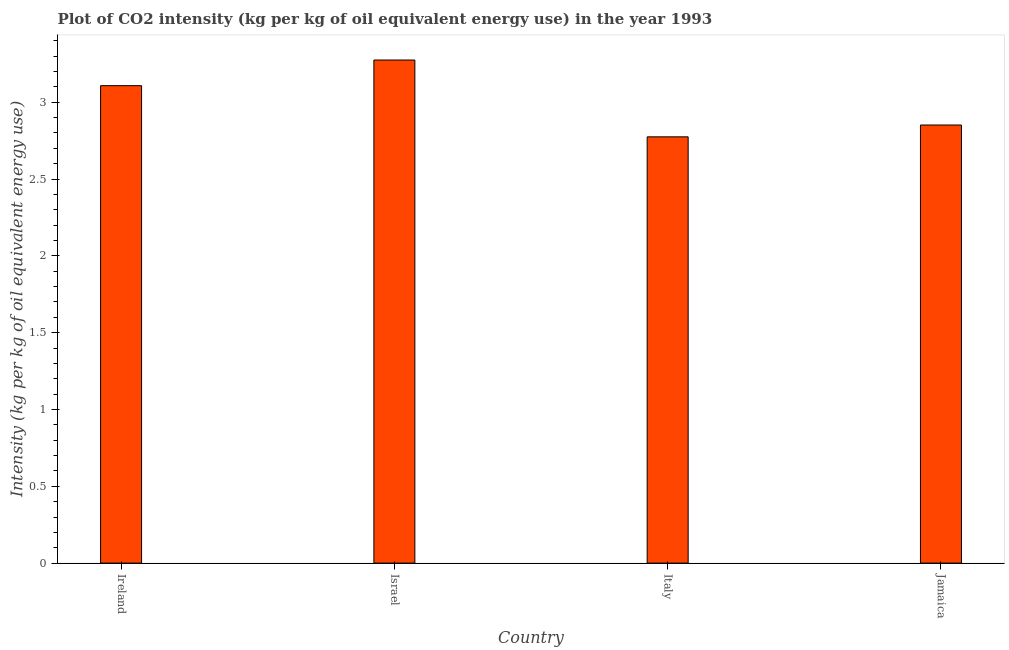Does the graph contain any zero values?
Offer a very short reply. No. What is the title of the graph?
Provide a short and direct response. Plot of CO2 intensity (kg per kg of oil equivalent energy use) in the year 1993. What is the label or title of the Y-axis?
Your answer should be very brief. Intensity (kg per kg of oil equivalent energy use). What is the co2 intensity in Jamaica?
Keep it short and to the point. 2.85. Across all countries, what is the maximum co2 intensity?
Ensure brevity in your answer.  3.27. Across all countries, what is the minimum co2 intensity?
Ensure brevity in your answer.  2.77. In which country was the co2 intensity minimum?
Offer a terse response. Italy. What is the sum of the co2 intensity?
Your response must be concise. 12.01. What is the difference between the co2 intensity in Israel and Jamaica?
Your answer should be very brief. 0.42. What is the average co2 intensity per country?
Your answer should be compact. 3. What is the median co2 intensity?
Provide a short and direct response. 2.98. In how many countries, is the co2 intensity greater than 2.7 kg?
Keep it short and to the point. 4. What is the ratio of the co2 intensity in Ireland to that in Israel?
Your answer should be compact. 0.95. Is the co2 intensity in Ireland less than that in Jamaica?
Offer a very short reply. No. Is the difference between the co2 intensity in Israel and Jamaica greater than the difference between any two countries?
Ensure brevity in your answer.  No. What is the difference between the highest and the second highest co2 intensity?
Make the answer very short. 0.17. In how many countries, is the co2 intensity greater than the average co2 intensity taken over all countries?
Your response must be concise. 2. How many bars are there?
Your response must be concise. 4. Are all the bars in the graph horizontal?
Ensure brevity in your answer.  No. How many countries are there in the graph?
Your answer should be compact. 4. Are the values on the major ticks of Y-axis written in scientific E-notation?
Keep it short and to the point. No. What is the Intensity (kg per kg of oil equivalent energy use) of Ireland?
Your response must be concise. 3.11. What is the Intensity (kg per kg of oil equivalent energy use) of Israel?
Offer a terse response. 3.27. What is the Intensity (kg per kg of oil equivalent energy use) in Italy?
Your answer should be compact. 2.77. What is the Intensity (kg per kg of oil equivalent energy use) in Jamaica?
Keep it short and to the point. 2.85. What is the difference between the Intensity (kg per kg of oil equivalent energy use) in Ireland and Israel?
Ensure brevity in your answer.  -0.17. What is the difference between the Intensity (kg per kg of oil equivalent energy use) in Ireland and Italy?
Make the answer very short. 0.33. What is the difference between the Intensity (kg per kg of oil equivalent energy use) in Ireland and Jamaica?
Ensure brevity in your answer.  0.26. What is the difference between the Intensity (kg per kg of oil equivalent energy use) in Israel and Italy?
Your response must be concise. 0.5. What is the difference between the Intensity (kg per kg of oil equivalent energy use) in Israel and Jamaica?
Your answer should be compact. 0.42. What is the difference between the Intensity (kg per kg of oil equivalent energy use) in Italy and Jamaica?
Provide a short and direct response. -0.08. What is the ratio of the Intensity (kg per kg of oil equivalent energy use) in Ireland to that in Israel?
Provide a succinct answer. 0.95. What is the ratio of the Intensity (kg per kg of oil equivalent energy use) in Ireland to that in Italy?
Your response must be concise. 1.12. What is the ratio of the Intensity (kg per kg of oil equivalent energy use) in Ireland to that in Jamaica?
Provide a short and direct response. 1.09. What is the ratio of the Intensity (kg per kg of oil equivalent energy use) in Israel to that in Italy?
Provide a succinct answer. 1.18. What is the ratio of the Intensity (kg per kg of oil equivalent energy use) in Israel to that in Jamaica?
Offer a terse response. 1.15. What is the ratio of the Intensity (kg per kg of oil equivalent energy use) in Italy to that in Jamaica?
Provide a short and direct response. 0.97. 